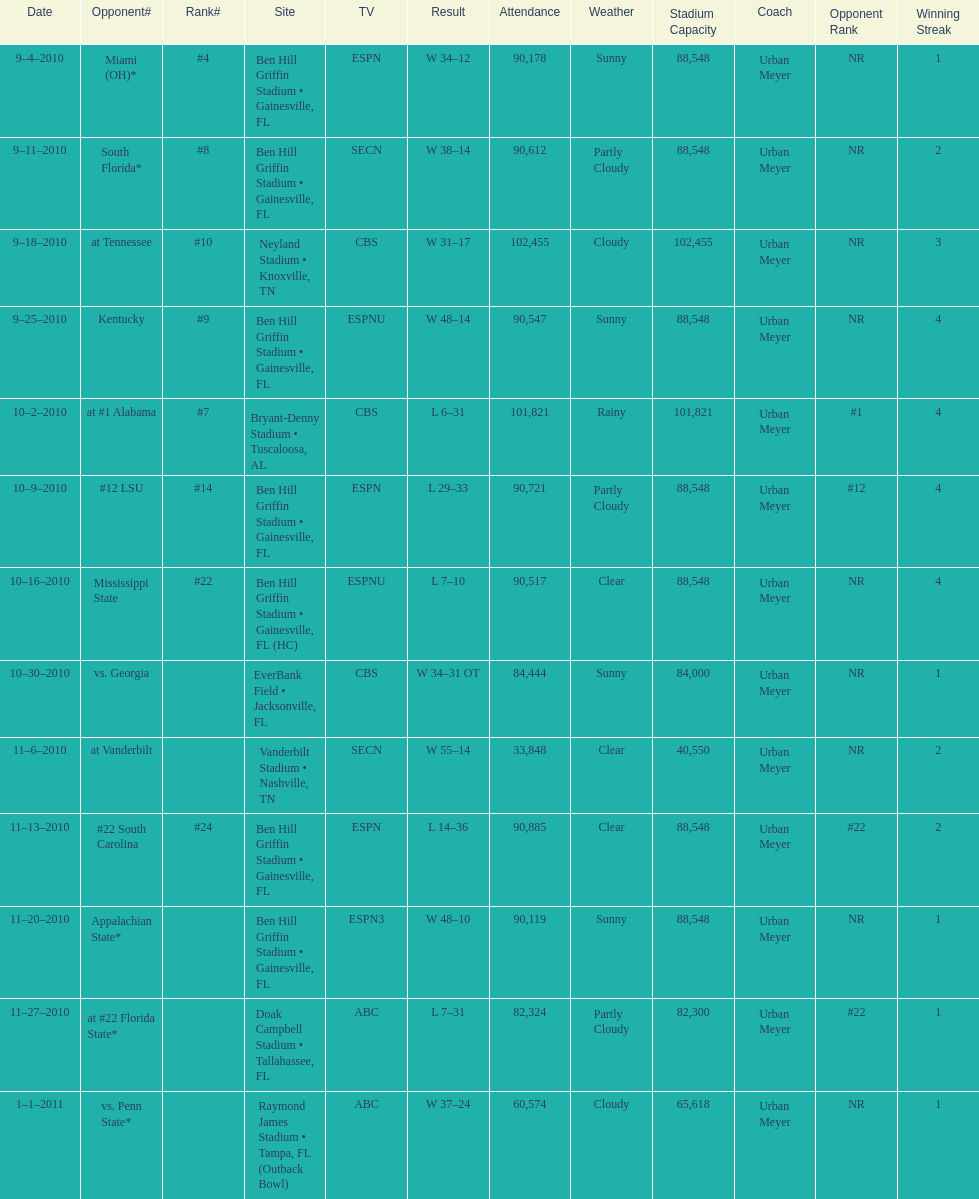How many games did the university of florida win by at least 10 points? 7. 